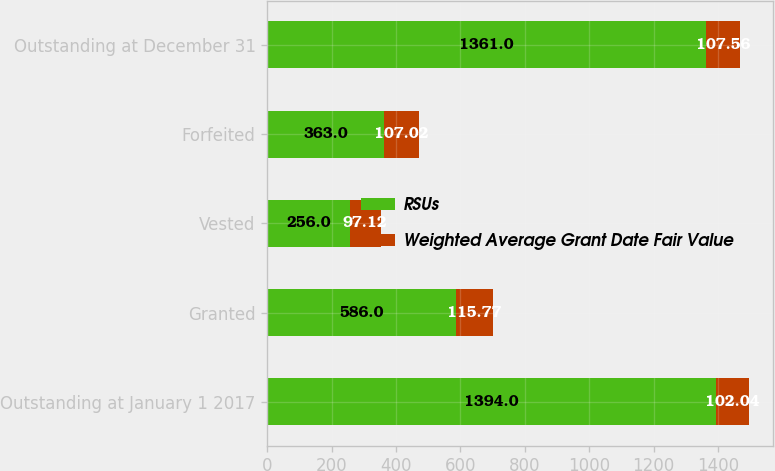<chart> <loc_0><loc_0><loc_500><loc_500><stacked_bar_chart><ecel><fcel>Outstanding at January 1 2017<fcel>Granted<fcel>Vested<fcel>Forfeited<fcel>Outstanding at December 31<nl><fcel>RSUs<fcel>1394<fcel>586<fcel>256<fcel>363<fcel>1361<nl><fcel>Weighted Average Grant Date Fair Value<fcel>102.04<fcel>115.77<fcel>97.12<fcel>107.02<fcel>107.56<nl></chart> 